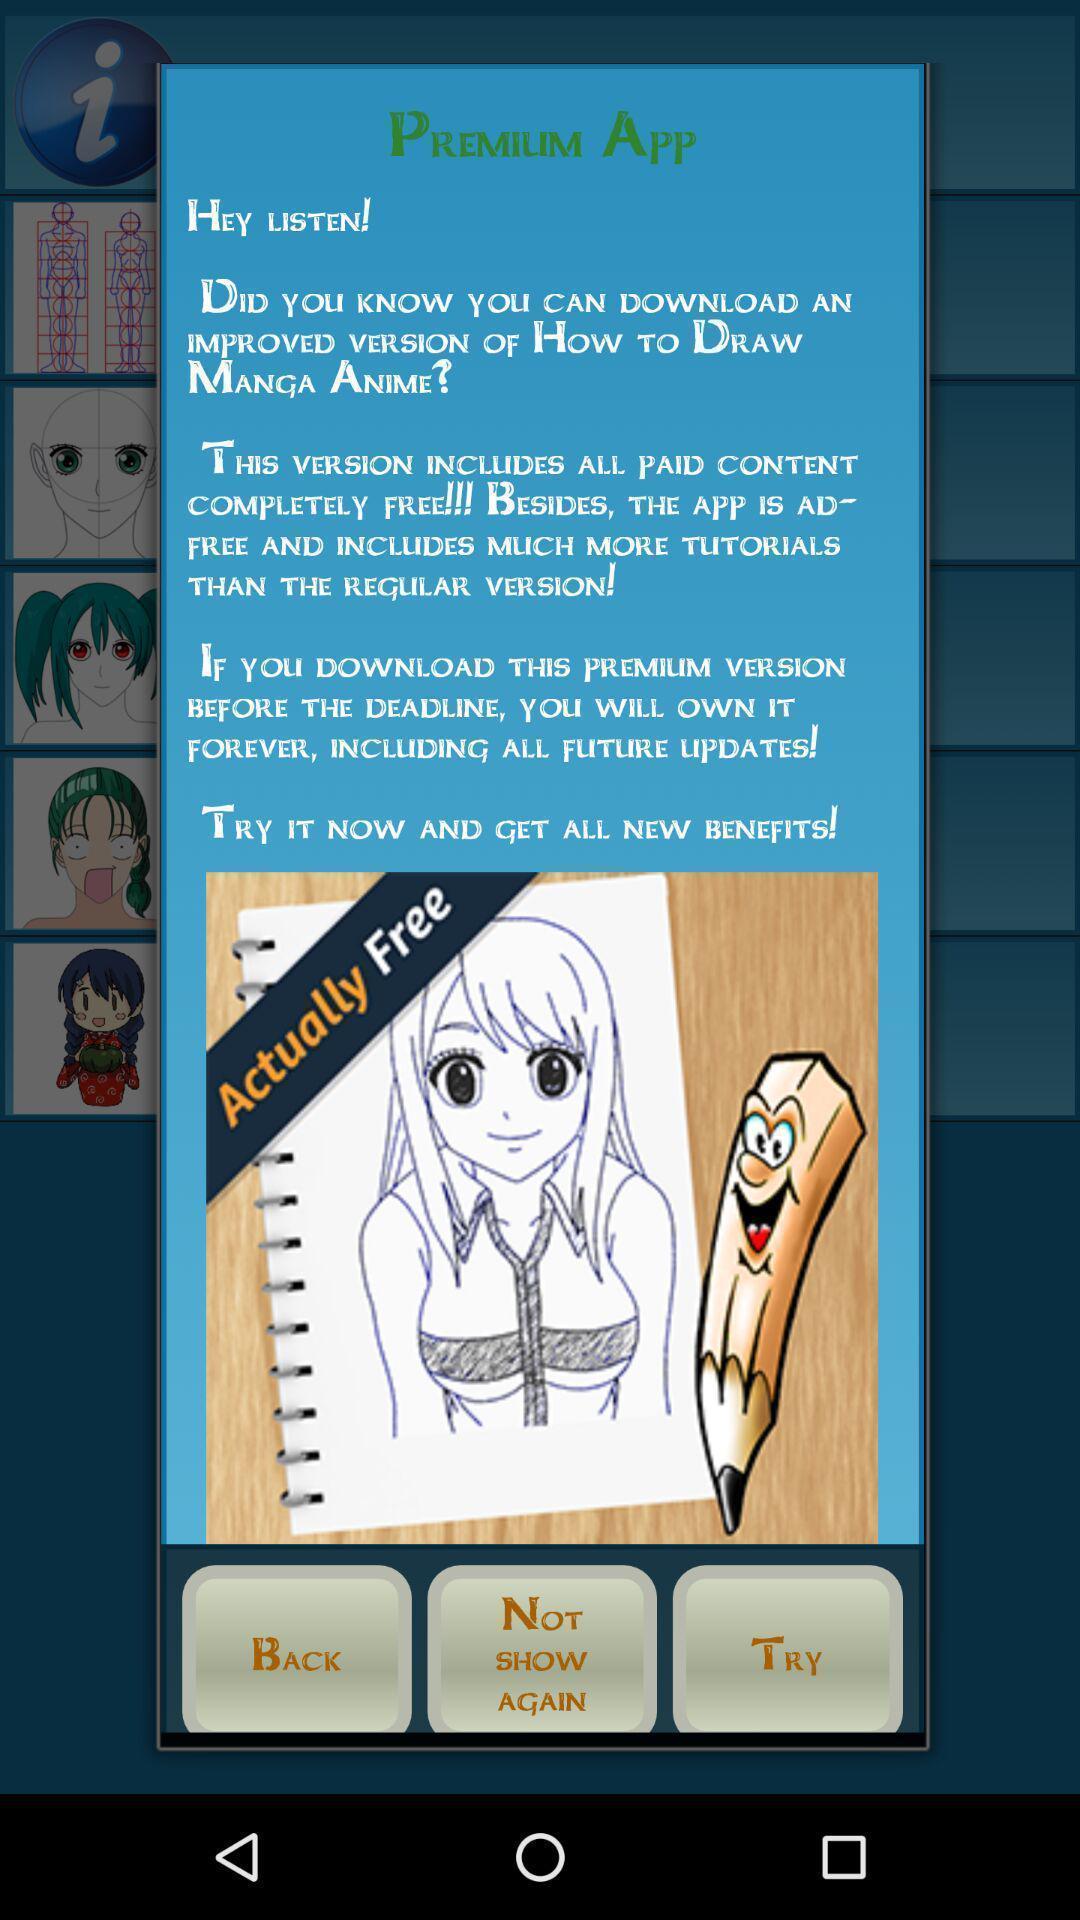Provide a textual representation of this image. Popup displaying premium information with options. 